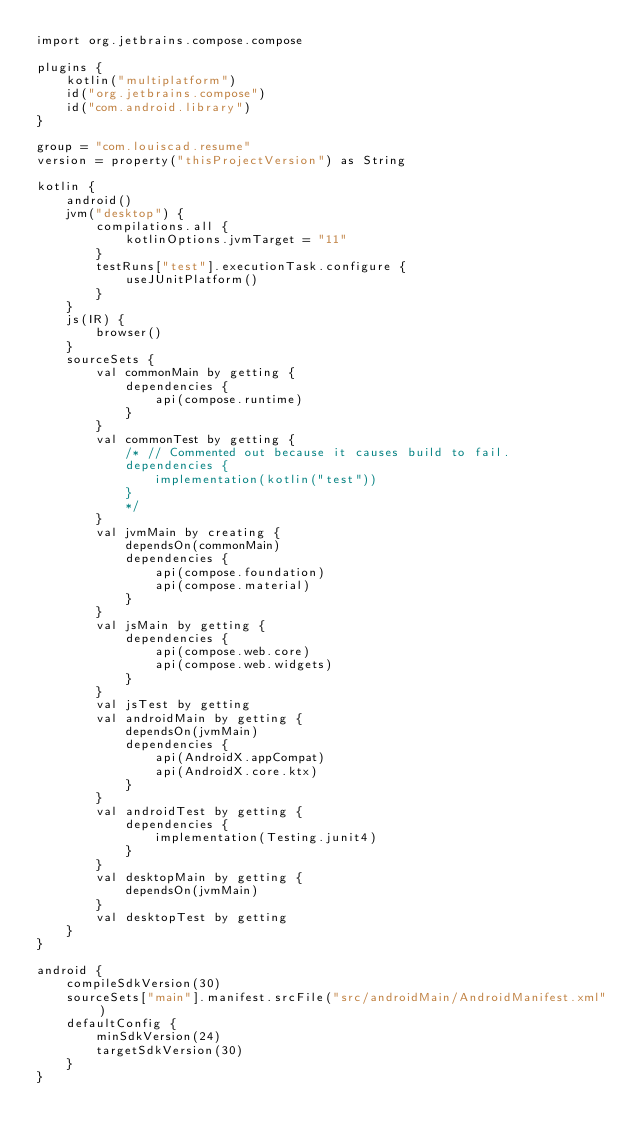Convert code to text. <code><loc_0><loc_0><loc_500><loc_500><_Kotlin_>import org.jetbrains.compose.compose

plugins {
    kotlin("multiplatform")
    id("org.jetbrains.compose")
    id("com.android.library")
}

group = "com.louiscad.resume"
version = property("thisProjectVersion") as String

kotlin {
    android()
    jvm("desktop") {
        compilations.all {
            kotlinOptions.jvmTarget = "11"
        }
        testRuns["test"].executionTask.configure {
            useJUnitPlatform()
        }
    }
    js(IR) {
        browser()
    }
    sourceSets {
        val commonMain by getting {
            dependencies {
                api(compose.runtime)
            }
        }
        val commonTest by getting {
            /* // Commented out because it causes build to fail.
            dependencies {
                implementation(kotlin("test"))
            }
            */
        }
        val jvmMain by creating {
            dependsOn(commonMain)
            dependencies {
                api(compose.foundation)
                api(compose.material)
            }
        }
        val jsMain by getting {
            dependencies {
                api(compose.web.core)
                api(compose.web.widgets)
            }
        }
        val jsTest by getting
        val androidMain by getting {
            dependsOn(jvmMain)
            dependencies {
                api(AndroidX.appCompat)
                api(AndroidX.core.ktx)
            }
        }
        val androidTest by getting {
            dependencies {
                implementation(Testing.junit4)
            }
        }
        val desktopMain by getting {
            dependsOn(jvmMain)
        }
        val desktopTest by getting
    }
}

android {
    compileSdkVersion(30)
    sourceSets["main"].manifest.srcFile("src/androidMain/AndroidManifest.xml")
    defaultConfig {
        minSdkVersion(24)
        targetSdkVersion(30)
    }
}
</code> 